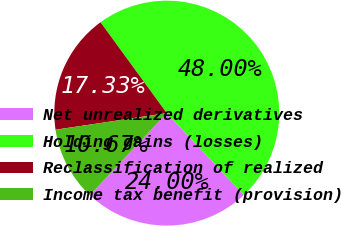Convert chart to OTSL. <chart><loc_0><loc_0><loc_500><loc_500><pie_chart><fcel>Net unrealized derivatives<fcel>Holding gains (losses)<fcel>Reclassification of realized<fcel>Income tax benefit (provision)<nl><fcel>24.0%<fcel>48.0%<fcel>17.33%<fcel>10.67%<nl></chart> 